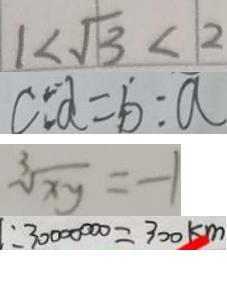<formula> <loc_0><loc_0><loc_500><loc_500>1 < \sqrt { 3 } < 2 
 C : d = b : a 
 \sqrt [ 3 ] { x y } = - 1 
 : 3 0 0 0 0 0 0 0 = 3 0 0 k m</formula> 